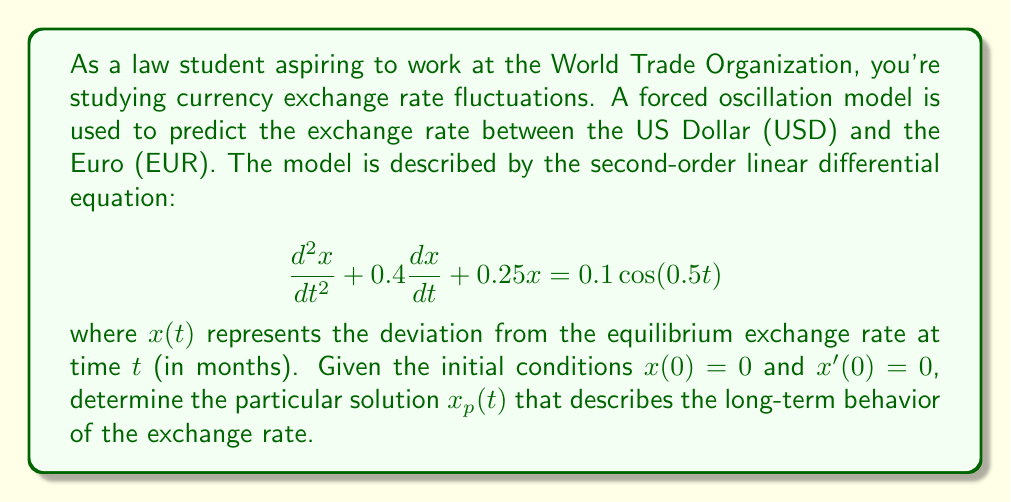Can you answer this question? To solve this problem, we'll follow these steps:

1) For a forced oscillation model with a cosine forcing term, we expect the particular solution to have the form:

   $x_p(t) = A\cos(0.5t) + B\sin(0.5t)$

2) We need to find the values of $A$ and $B$. To do this, we'll substitute $x_p(t)$ into the original differential equation:

   $$\frac{d^2x_p}{dt^2} + 0.4\frac{dx_p}{dt} + 0.25x_p = 0.1\cos(0.5t)$$

3) First, let's calculate the derivatives:

   $\frac{dx_p}{dt} = -0.5A\sin(0.5t) + 0.5B\cos(0.5t)$
   
   $\frac{d^2x_p}{dt^2} = -0.25A\cos(0.5t) - 0.25B\sin(0.5t)$

4) Substituting these into the left side of the equation:

   $(-0.25A\cos(0.5t) - 0.25B\sin(0.5t)) + 0.4(-0.5A\sin(0.5t) + 0.5B\cos(0.5t)) + 0.25(A\cos(0.5t) + B\sin(0.5t))$

5) Simplifying and grouping $\cos(0.5t)$ and $\sin(0.5t)$ terms:

   $(0.2B)\cos(0.5t) + (-0.2A)\sin(0.5t)$

6) Equating coefficients with the right side of the equation:

   $0.2B = 0.1$
   $-0.2A = 0$

7) Solving these equations:

   $B = 0.5$
   $A = 0$

8) Therefore, the particular solution is:

   $x_p(t) = 0.5\sin(0.5t)$

This solution represents the long-term behavior of the exchange rate fluctuations, as it doesn't decay over time like the complementary solution would.
Answer: $x_p(t) = 0.5\sin(0.5t)$ 